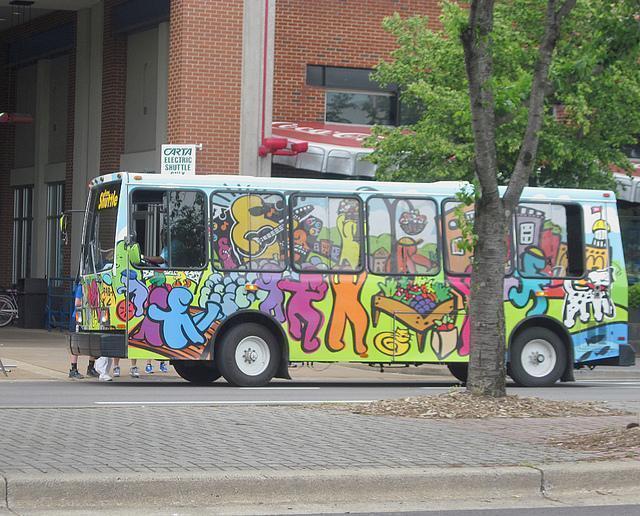What is the profession of the man seen on the bus?
Pick the right solution, then justify: 'Answer: answer
Rationale: rationale.'
Options: Officer, doctor, judge, driver. Answer: driver.
Rationale: He is in front of the steering wheel and is also in the drivers seat, indicating he is the driver. 